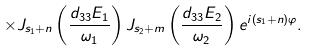Convert formula to latex. <formula><loc_0><loc_0><loc_500><loc_500>\times J _ { s _ { 1 } + n } \left ( \frac { d _ { 3 3 } E _ { 1 } } { \omega _ { 1 } } \right ) J _ { s _ { 2 } + m } \left ( \frac { d _ { 3 3 } E _ { 2 } } { \omega _ { 2 } } \right ) e ^ { i \left ( s _ { 1 } + n \right ) \varphi } .</formula> 